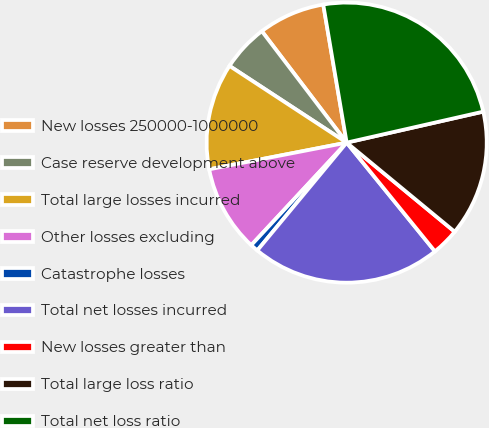<chart> <loc_0><loc_0><loc_500><loc_500><pie_chart><fcel>New losses 250000-1000000<fcel>Case reserve development above<fcel>Total large losses incurred<fcel>Other losses excluding<fcel>Catastrophe losses<fcel>Total net losses incurred<fcel>New losses greater than<fcel>Total large loss ratio<fcel>Total net loss ratio<nl><fcel>7.68%<fcel>5.42%<fcel>12.28%<fcel>10.02%<fcel>0.91%<fcel>21.87%<fcel>3.17%<fcel>14.53%<fcel>24.12%<nl></chart> 